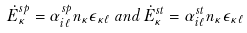Convert formula to latex. <formula><loc_0><loc_0><loc_500><loc_500>\dot { E } ^ { s p } _ { \kappa } = \alpha ^ { s p } _ { i \ell } n _ { \kappa } \epsilon _ { \kappa \ell } \, a n d \, \dot { E } ^ { s t } _ { \kappa } = \alpha ^ { s t } _ { i \ell } n _ { \kappa } \epsilon _ { \kappa \ell }</formula> 